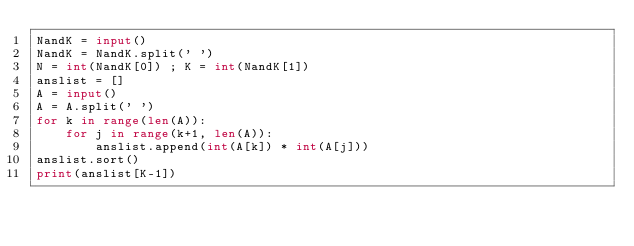<code> <loc_0><loc_0><loc_500><loc_500><_Python_>NandK = input()
NandK = NandK.split(' ')
N = int(NandK[0]) ; K = int(NandK[1])
anslist = []
A = input()
A = A.split(' ')
for k in range(len(A)):
    for j in range(k+1, len(A)):
        anslist.append(int(A[k]) * int(A[j]))
anslist.sort()
print(anslist[K-1])</code> 